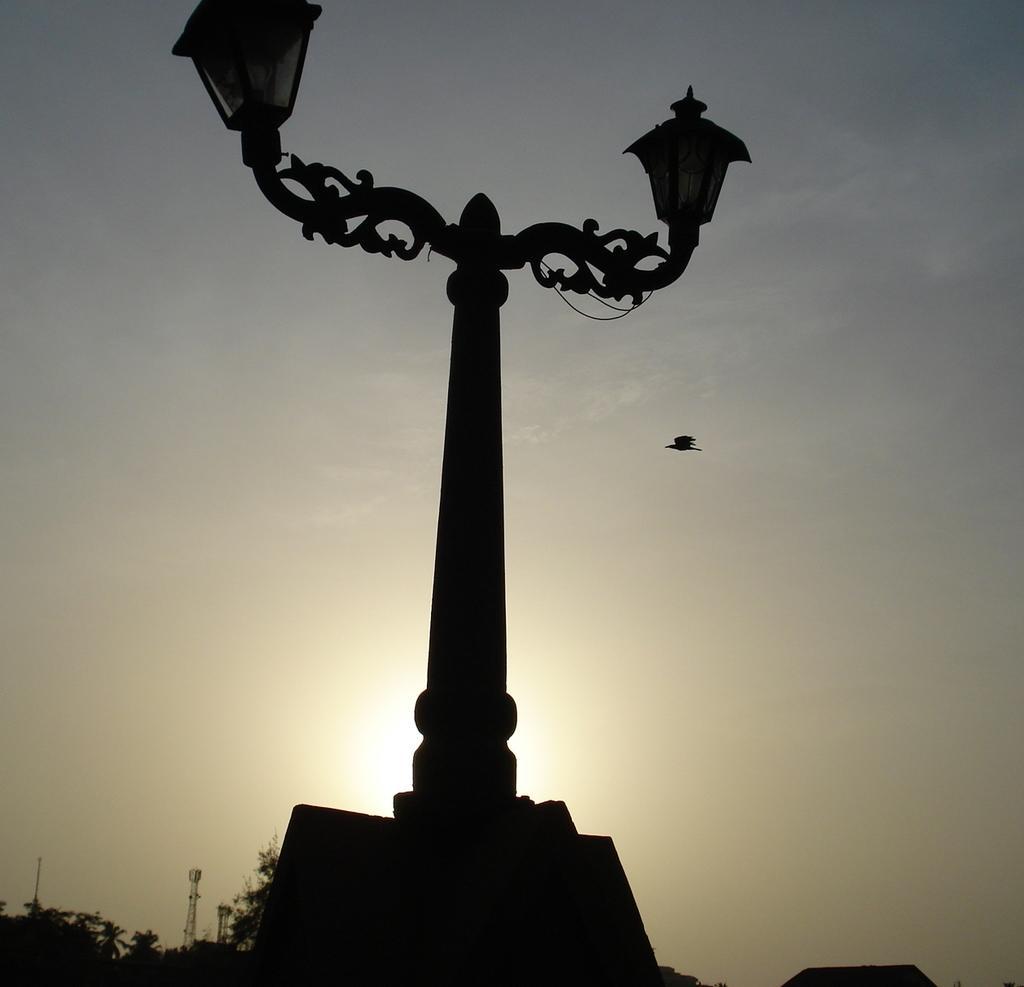Describe this image in one or two sentences. In this image we can see a pole with lights. Behind the pole we can see a bird flying and the sky. In the bottom left we can see the towers and trees. 